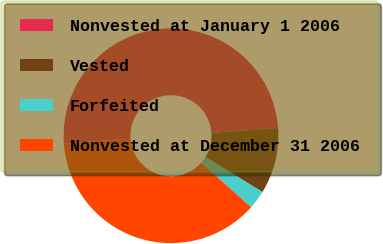<chart> <loc_0><loc_0><loc_500><loc_500><pie_chart><fcel>Nonvested at January 1 2006<fcel>Vested<fcel>Forfeited<fcel>Nonvested at December 31 2006<nl><fcel>50.0%<fcel>9.94%<fcel>2.8%<fcel>37.26%<nl></chart> 